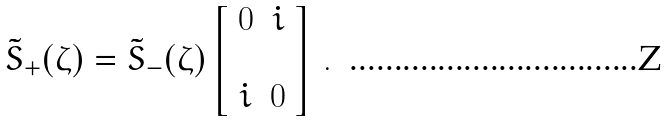<formula> <loc_0><loc_0><loc_500><loc_500>\tilde { S } _ { + } ( \zeta ) = \tilde { S } _ { - } ( \zeta ) \left [ \begin{array} { c c } 0 & i \\ \\ i & 0 \end{array} \right ] \, .</formula> 